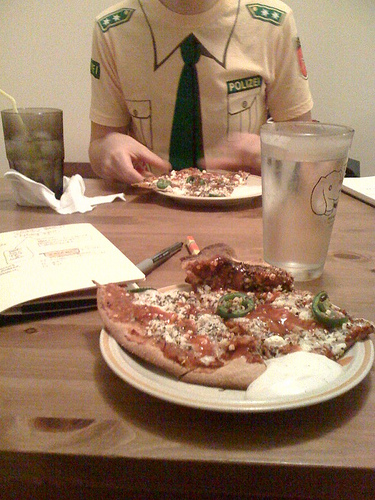Is there anything that suggests an activity or event? Besides the person's attire that suggests a uniform theme, there is also a piece of paper and a pen on the table, which might indicate the person was writing or drawing something. No other clear indicators of a specific activity or event are visible. 